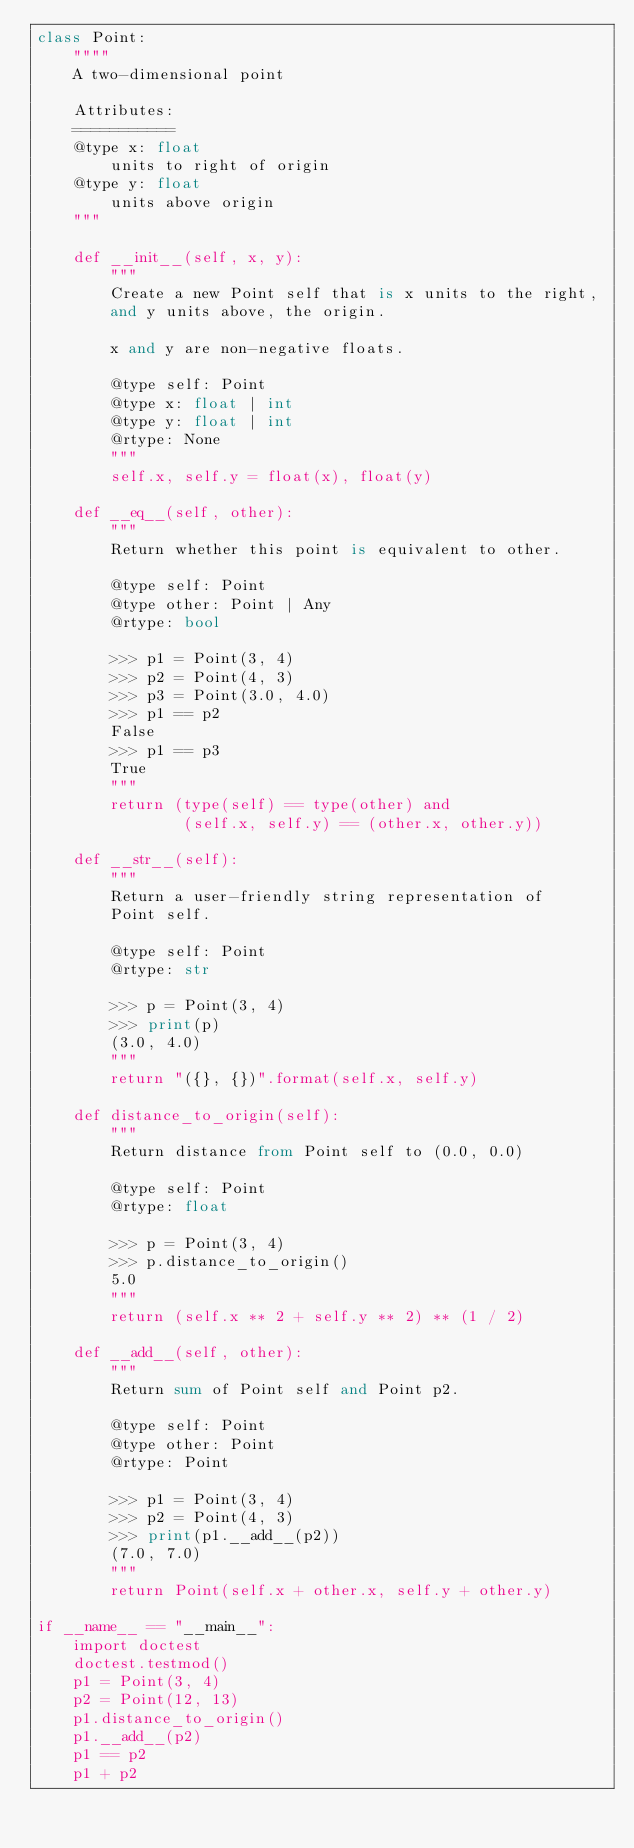Convert code to text. <code><loc_0><loc_0><loc_500><loc_500><_Python_>class Point:
    """"
    A two-dimensional point

    Attributes:
    ===========
    @type x: float
        units to right of origin
    @type y: float
        units above origin
    """

    def __init__(self, x, y):
        """
        Create a new Point self that is x units to the right,
        and y units above, the origin.

        x and y are non-negative floats.

        @type self: Point
        @type x: float | int
        @type y: float | int
        @rtype: None
        """
        self.x, self.y = float(x), float(y)

    def __eq__(self, other):
        """
        Return whether this point is equivalent to other.

        @type self: Point
        @type other: Point | Any
        @rtype: bool

        >>> p1 = Point(3, 4)
        >>> p2 = Point(4, 3)
        >>> p3 = Point(3.0, 4.0)
        >>> p1 == p2
        False
        >>> p1 == p3
        True
        """
        return (type(self) == type(other) and
                (self.x, self.y) == (other.x, other.y))

    def __str__(self):
        """
        Return a user-friendly string representation of
        Point self.

        @type self: Point
        @rtype: str

        >>> p = Point(3, 4)
        >>> print(p)
        (3.0, 4.0)
        """
        return "({}, {})".format(self.x, self.y)

    def distance_to_origin(self):
        """
        Return distance from Point self to (0.0, 0.0)

        @type self: Point
        @rtype: float

        >>> p = Point(3, 4)
        >>> p.distance_to_origin()
        5.0
        """
        return (self.x ** 2 + self.y ** 2) ** (1 / 2)

    def __add__(self, other):
        """
        Return sum of Point self and Point p2.

        @type self: Point
        @type other: Point
        @rtype: Point

        >>> p1 = Point(3, 4)
        >>> p2 = Point(4, 3)
        >>> print(p1.__add__(p2))
        (7.0, 7.0)
        """
        return Point(self.x + other.x, self.y + other.y)

if __name__ == "__main__":
    import doctest
    doctest.testmod()
    p1 = Point(3, 4)
    p2 = Point(12, 13)
    p1.distance_to_origin()
    p1.__add__(p2)
    p1 == p2
    p1 + p2
</code> 